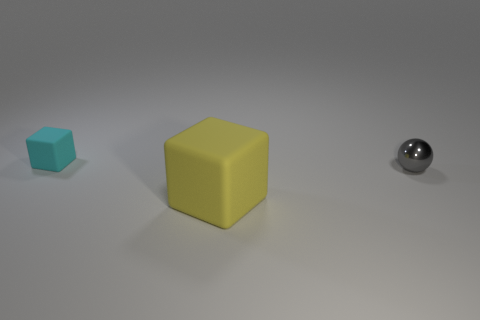Are there any other things that are the same size as the yellow rubber cube?
Provide a succinct answer. No. What size is the other rubber object that is the same shape as the small rubber thing?
Your answer should be very brief. Large. Is the number of cyan things less than the number of tiny yellow cubes?
Your response must be concise. No. How many yellow things are spheres or rubber objects?
Make the answer very short. 1. What number of small objects are both to the left of the large thing and on the right side of the large thing?
Ensure brevity in your answer.  0. Are the small cube and the small gray object made of the same material?
Provide a succinct answer. No. There is a object that is the same size as the shiny sphere; what shape is it?
Make the answer very short. Cube. Is the number of cyan objects greater than the number of gray matte things?
Make the answer very short. Yes. What material is the thing that is left of the gray sphere and in front of the tiny cyan rubber thing?
Offer a very short reply. Rubber. How many other things are the same material as the large object?
Your response must be concise. 1. 